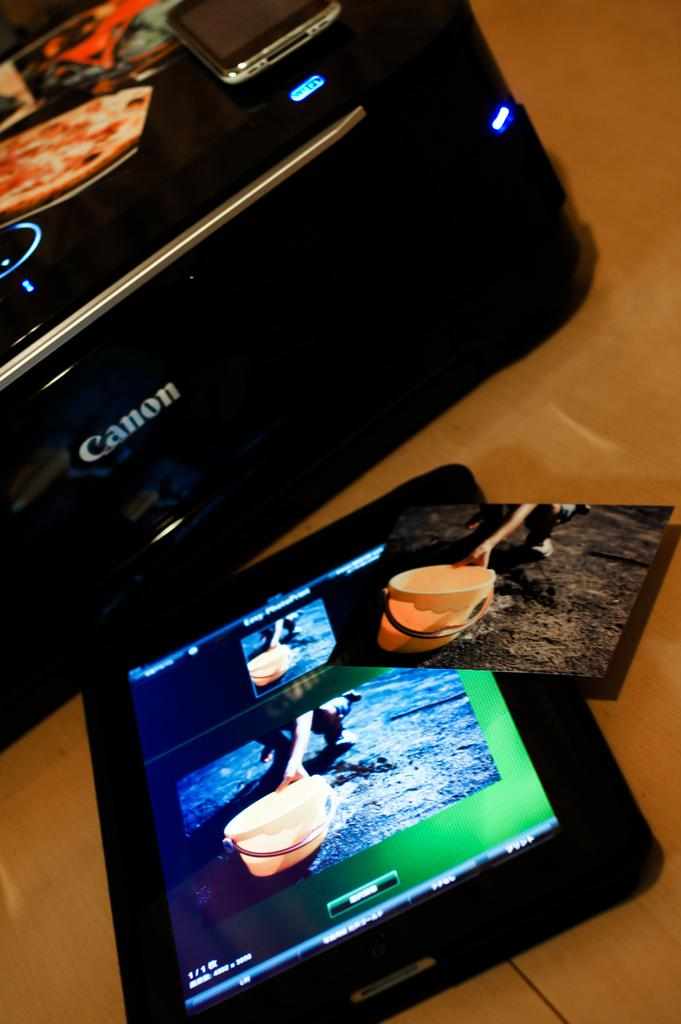What electronic device is present in the image? There is a mobile phone in the image. Where is the mobile phone located? The mobile phone is on a canon printer. What other electronic device can be seen in the image? There is a tablet in the image. Is there any visual content displayed in the image? Yes, there is a photo on an object in the image. What type of gold jewelry is visible on the edge of the sidewalk in the image? There is no sidewalk or gold jewelry present in the image. 